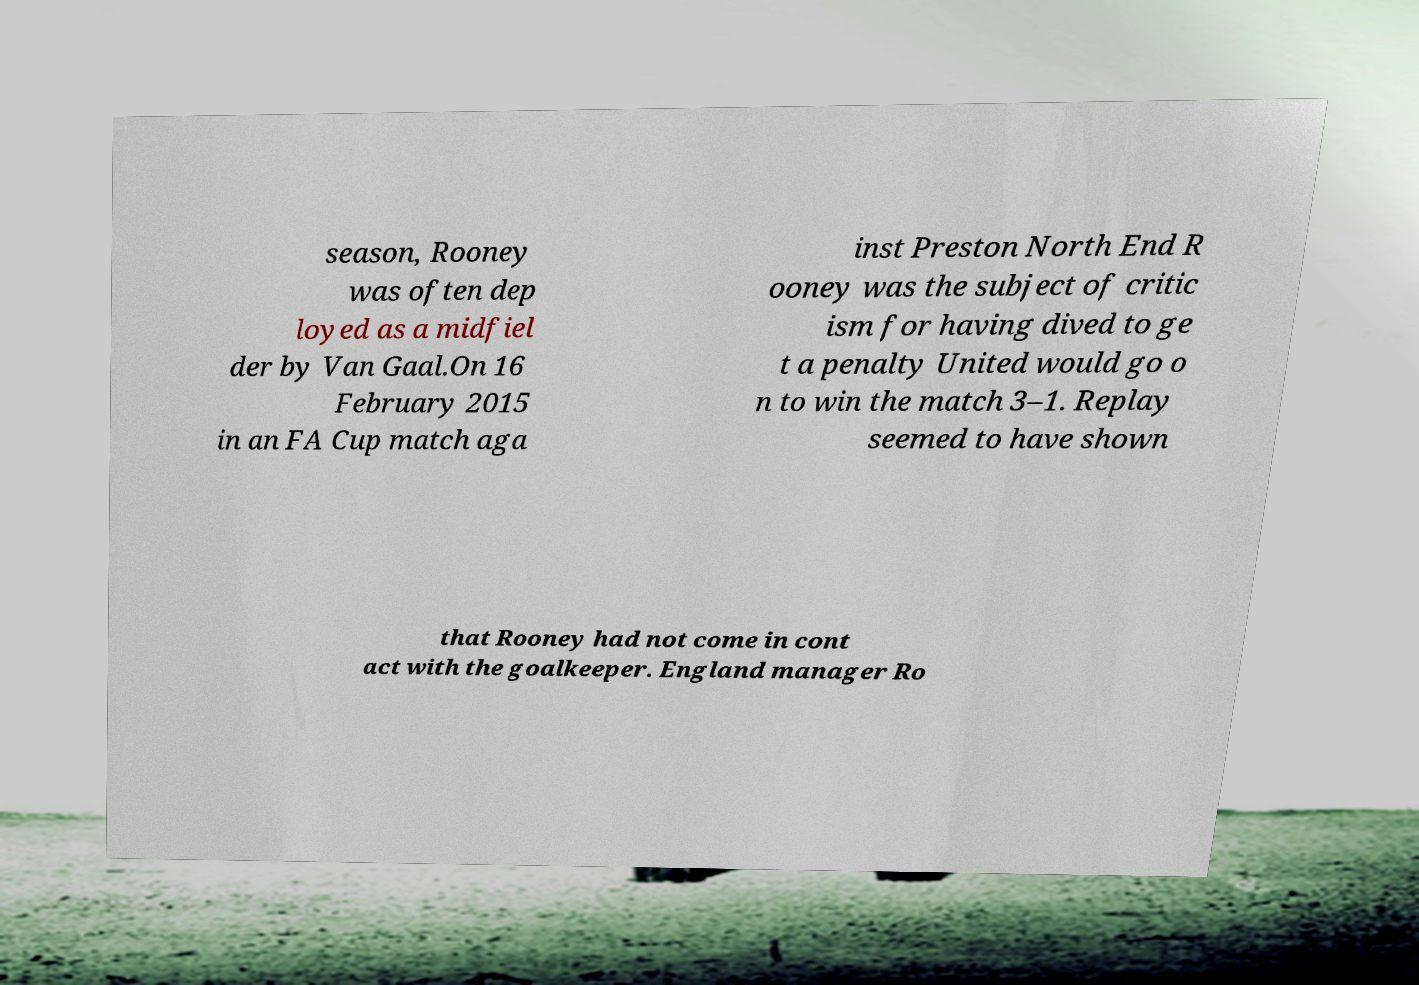Can you accurately transcribe the text from the provided image for me? season, Rooney was often dep loyed as a midfiel der by Van Gaal.On 16 February 2015 in an FA Cup match aga inst Preston North End R ooney was the subject of critic ism for having dived to ge t a penalty United would go o n to win the match 3–1. Replay seemed to have shown that Rooney had not come in cont act with the goalkeeper. England manager Ro 